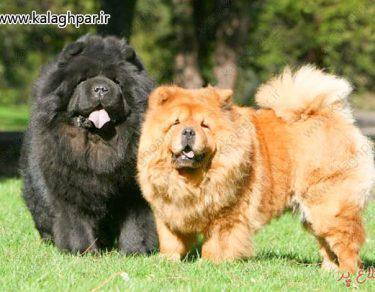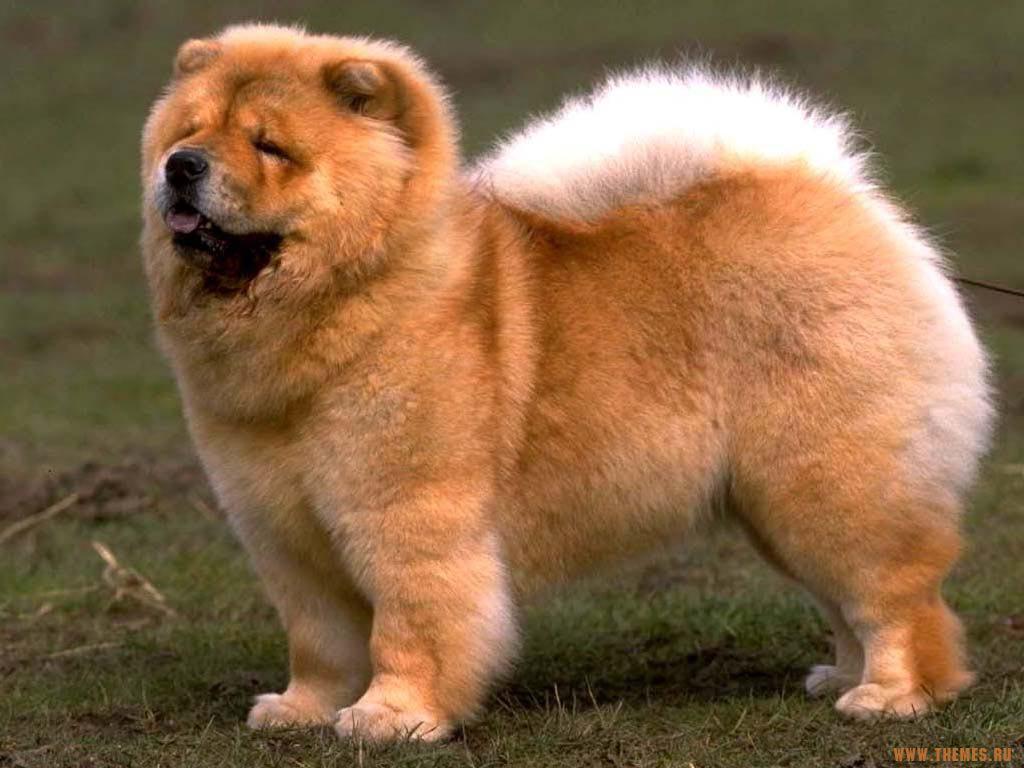The first image is the image on the left, the second image is the image on the right. Considering the images on both sides, is "There are three dogs" valid? Answer yes or no. Yes. 